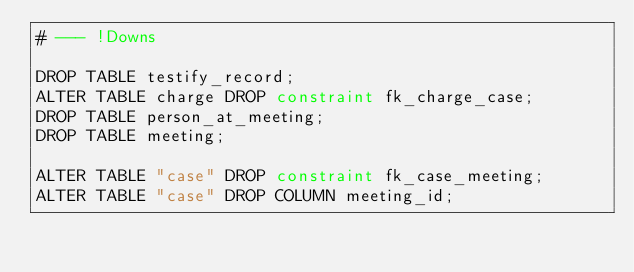<code> <loc_0><loc_0><loc_500><loc_500><_SQL_># --- !Downs

DROP TABLE testify_record;
ALTER TABLE charge DROP constraint fk_charge_case;
DROP TABLE person_at_meeting;
DROP TABLE meeting;

ALTER TABLE "case" DROP constraint fk_case_meeting;
ALTER TABLE "case" DROP COLUMN meeting_id;

</code> 